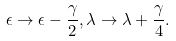Convert formula to latex. <formula><loc_0><loc_0><loc_500><loc_500>\epsilon \rightarrow \epsilon - \frac { \gamma } { 2 } , \lambda \rightarrow \lambda + \frac { \gamma } { 4 } .</formula> 